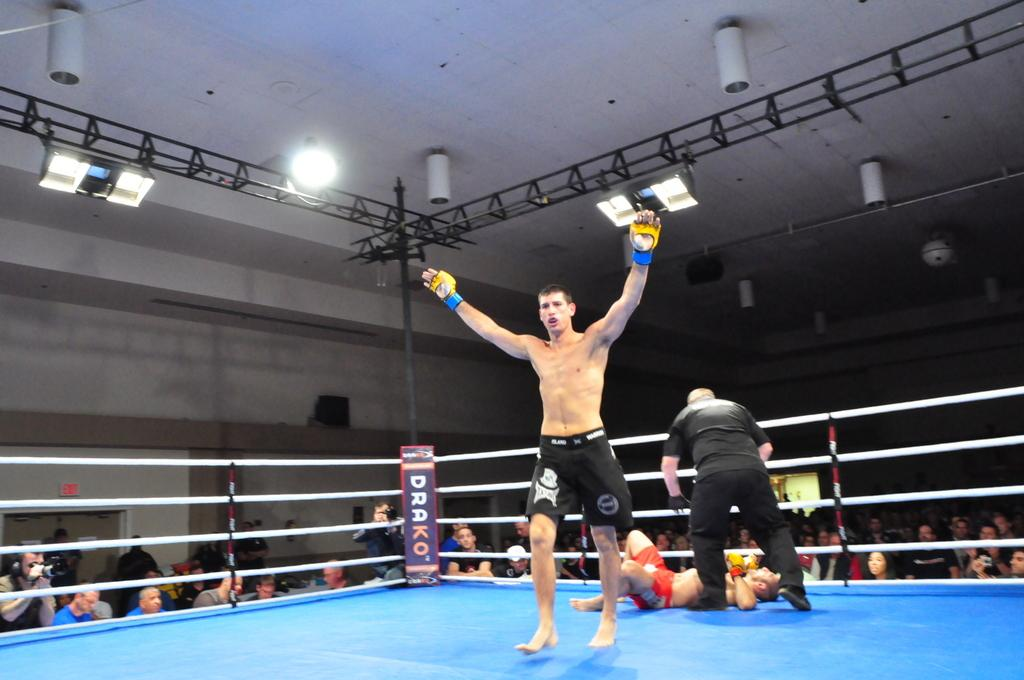How many people are present in the image? There are three people in the image. What are the positions of the people in the image? Two of the people are standing, and one person is lying down. What can be seen in the background of the image? There is a fence and people visible in the background of the image. What type of laborer can be seen working in the background of the image? There is no laborer present in the image, and no work-related activities are depicted. 